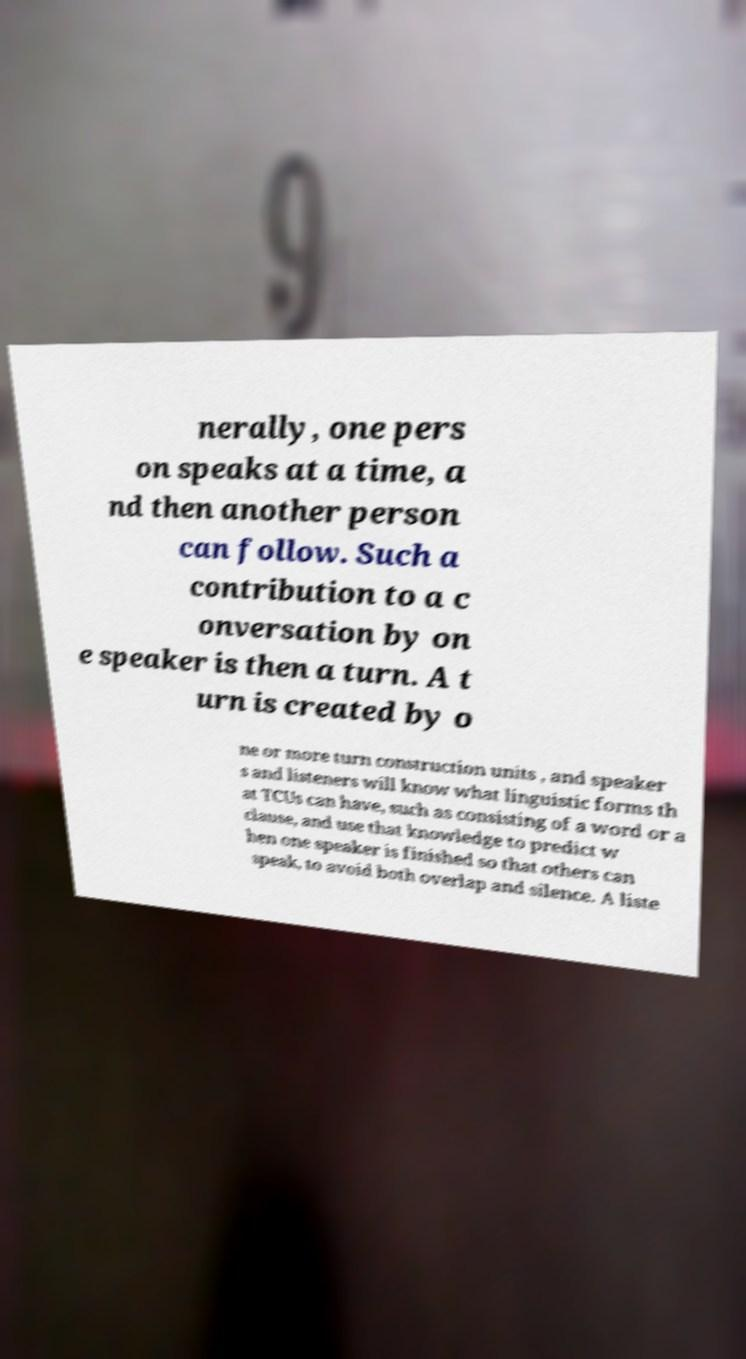Please identify and transcribe the text found in this image. nerally, one pers on speaks at a time, a nd then another person can follow. Such a contribution to a c onversation by on e speaker is then a turn. A t urn is created by o ne or more turn construction units , and speaker s and listeners will know what linguistic forms th at TCUs can have, such as consisting of a word or a clause, and use that knowledge to predict w hen one speaker is finished so that others can speak, to avoid both overlap and silence. A liste 